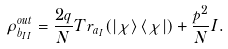<formula> <loc_0><loc_0><loc_500><loc_500>\rho _ { b _ { I I } } ^ { o u t } = \frac { 2 q } { N } T r _ { a _ { I } } ( \left | \chi \right \rangle \left \langle \chi \right | ) + \frac { p ^ { 2 } } { N } I .</formula> 